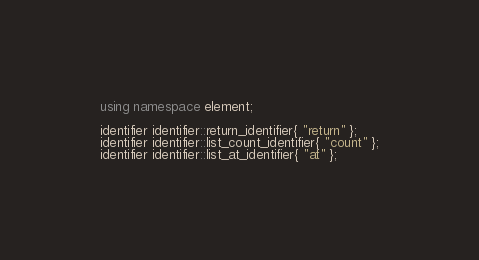Convert code to text. <code><loc_0><loc_0><loc_500><loc_500><_C++_>
using namespace element;

identifier identifier::return_identifier{ "return" };
identifier identifier::list_count_identifier{ "count" };
identifier identifier::list_at_identifier{ "at" };</code> 